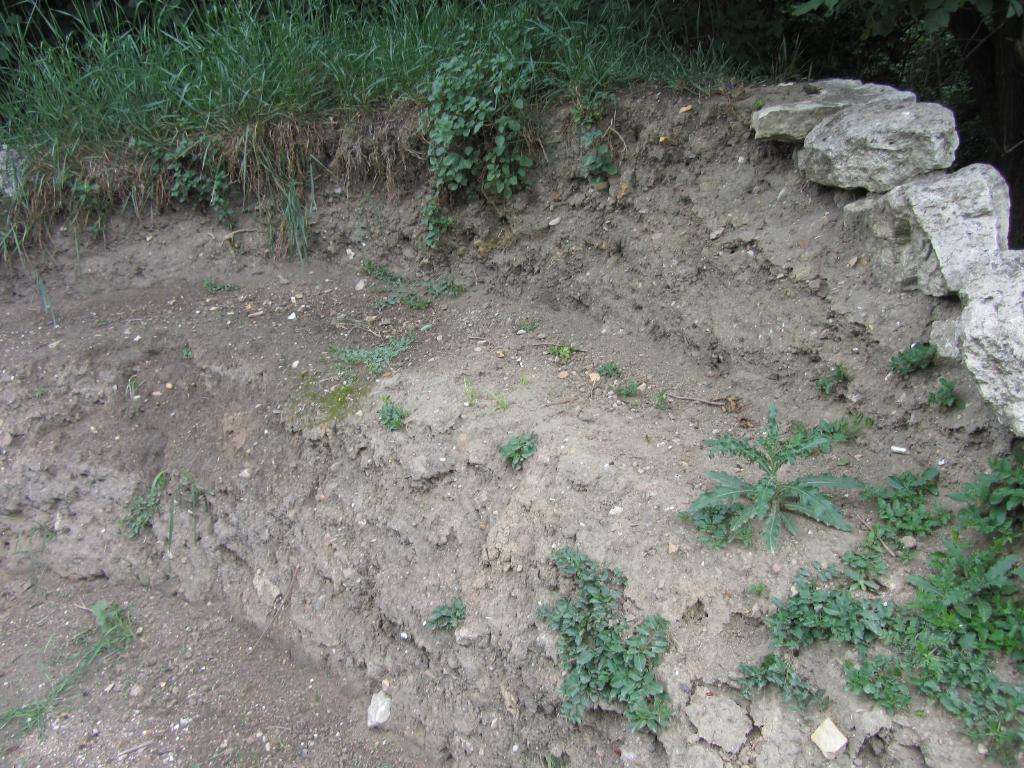Where was the image taken? The image was taken outside. What can be seen at the bottom of the image? The ground is visible at the bottom of the image. What type of terrain is present on the ground? There are rocks and green grass on the ground. What can be seen on the right side of the image? A: There are small plants on the right side of the image. What is the title of the development project in the image? There is no development project or title present in the image; it features an outdoor scene with rocks, grass, and small plants. 